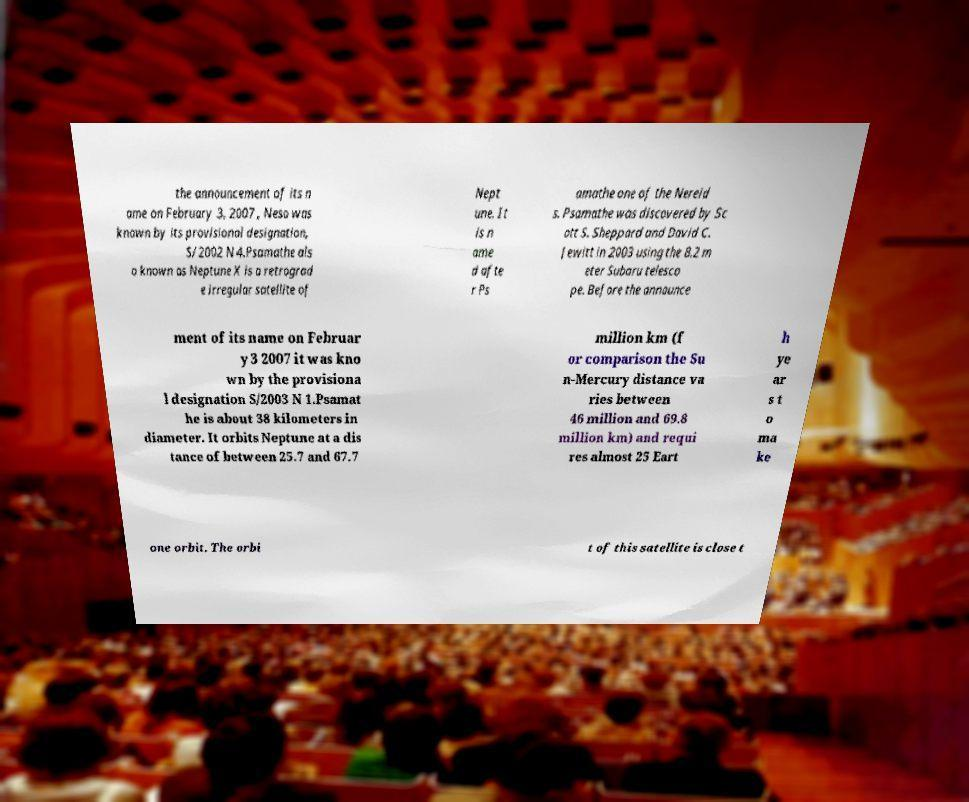What messages or text are displayed in this image? I need them in a readable, typed format. the announcement of its n ame on February 3, 2007 , Neso was known by its provisional designation, S/2002 N 4.Psamathe als o known as Neptune X is a retrograd e irregular satellite of Nept une. It is n ame d afte r Ps amathe one of the Nereid s. Psamathe was discovered by Sc ott S. Sheppard and David C. Jewitt in 2003 using the 8.2 m eter Subaru telesco pe. Before the announce ment of its name on Februar y 3 2007 it was kno wn by the provisiona l designation S/2003 N 1.Psamat he is about 38 kilometers in diameter. It orbits Neptune at a dis tance of between 25.7 and 67.7 million km (f or comparison the Su n-Mercury distance va ries between 46 million and 69.8 million km) and requi res almost 25 Eart h ye ar s t o ma ke one orbit. The orbi t of this satellite is close t 